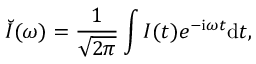<formula> <loc_0><loc_0><loc_500><loc_500>\breve { I } ( \omega ) = \frac { 1 } { \sqrt { 2 \pi } } \int I ( t ) e ^ { { - i } \omega t } { d } t ,</formula> 